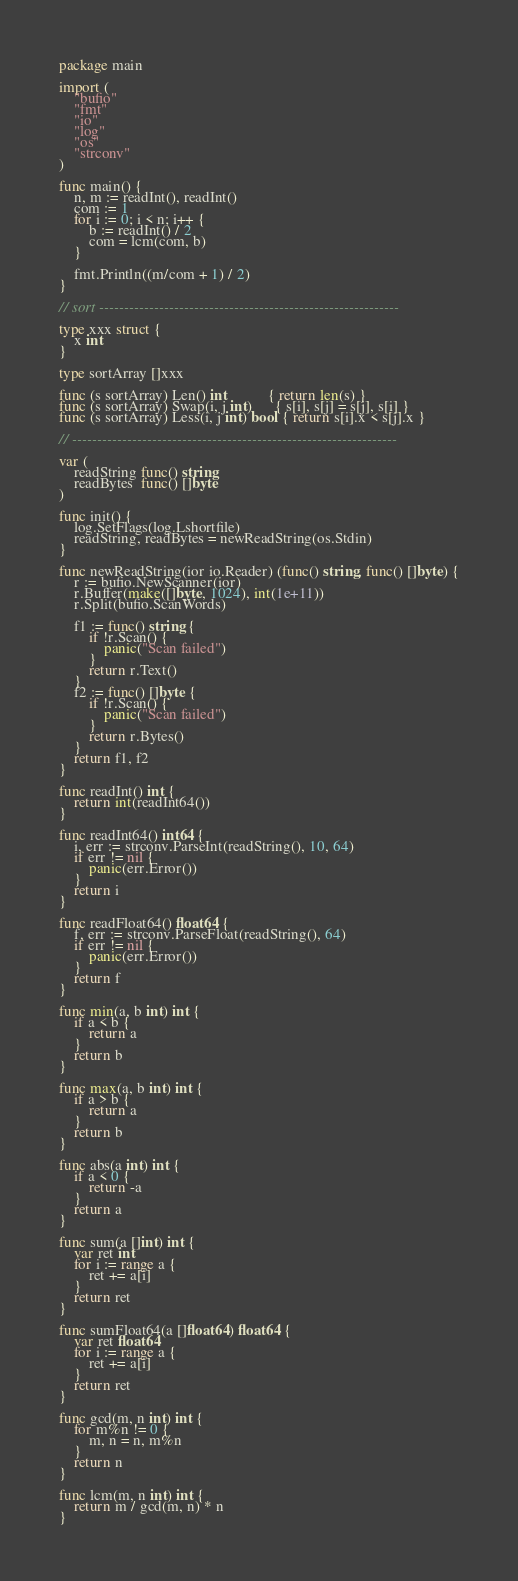<code> <loc_0><loc_0><loc_500><loc_500><_Go_>package main

import (
	"bufio"
	"fmt"
	"io"
	"log"
	"os"
	"strconv"
)

func main() {
	n, m := readInt(), readInt()
	com := 1
	for i := 0; i < n; i++ {
		b := readInt() / 2
		com = lcm(com, b)
	}

	fmt.Println((m/com + 1) / 2)
}

// sort ------------------------------------------------------------

type xxx struct {
	x int
}

type sortArray []xxx

func (s sortArray) Len() int           { return len(s) }
func (s sortArray) Swap(i, j int)      { s[i], s[j] = s[j], s[i] }
func (s sortArray) Less(i, j int) bool { return s[i].x < s[j].x }

// -----------------------------------------------------------------

var (
	readString func() string
	readBytes  func() []byte
)

func init() {
	log.SetFlags(log.Lshortfile)
	readString, readBytes = newReadString(os.Stdin)
}

func newReadString(ior io.Reader) (func() string, func() []byte) {
	r := bufio.NewScanner(ior)
	r.Buffer(make([]byte, 1024), int(1e+11))
	r.Split(bufio.ScanWords)

	f1 := func() string {
		if !r.Scan() {
			panic("Scan failed")
		}
		return r.Text()
	}
	f2 := func() []byte {
		if !r.Scan() {
			panic("Scan failed")
		}
		return r.Bytes()
	}
	return f1, f2
}

func readInt() int {
	return int(readInt64())
}

func readInt64() int64 {
	i, err := strconv.ParseInt(readString(), 10, 64)
	if err != nil {
		panic(err.Error())
	}
	return i
}

func readFloat64() float64 {
	f, err := strconv.ParseFloat(readString(), 64)
	if err != nil {
		panic(err.Error())
	}
	return f
}

func min(a, b int) int {
	if a < b {
		return a
	}
	return b
}

func max(a, b int) int {
	if a > b {
		return a
	}
	return b
}

func abs(a int) int {
	if a < 0 {
		return -a
	}
	return a
}

func sum(a []int) int {
	var ret int
	for i := range a {
		ret += a[i]
	}
	return ret
}

func sumFloat64(a []float64) float64 {
	var ret float64
	for i := range a {
		ret += a[i]
	}
	return ret
}

func gcd(m, n int) int {
	for m%n != 0 {
		m, n = n, m%n
	}
	return n
}

func lcm(m, n int) int {
	return m / gcd(m, n) * n
}
</code> 